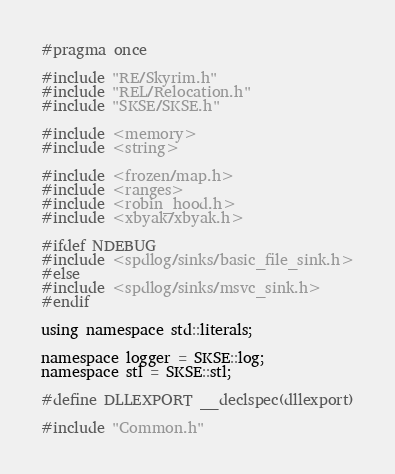Convert code to text. <code><loc_0><loc_0><loc_500><loc_500><_C_>#pragma once

#include "RE/Skyrim.h"
#include "REL/Relocation.h"
#include "SKSE/SKSE.h"

#include <memory>
#include <string>

#include <frozen/map.h>
#include <ranges>
#include <robin_hood.h>
#include <xbyak/xbyak.h>

#ifdef NDEBUG
#include <spdlog/sinks/basic_file_sink.h>
#else
#include <spdlog/sinks/msvc_sink.h>
#endif

using namespace std::literals;

namespace logger = SKSE::log;
namespace stl = SKSE::stl;

#define DLLEXPORT __declspec(dllexport)

#include "Common.h"
</code> 